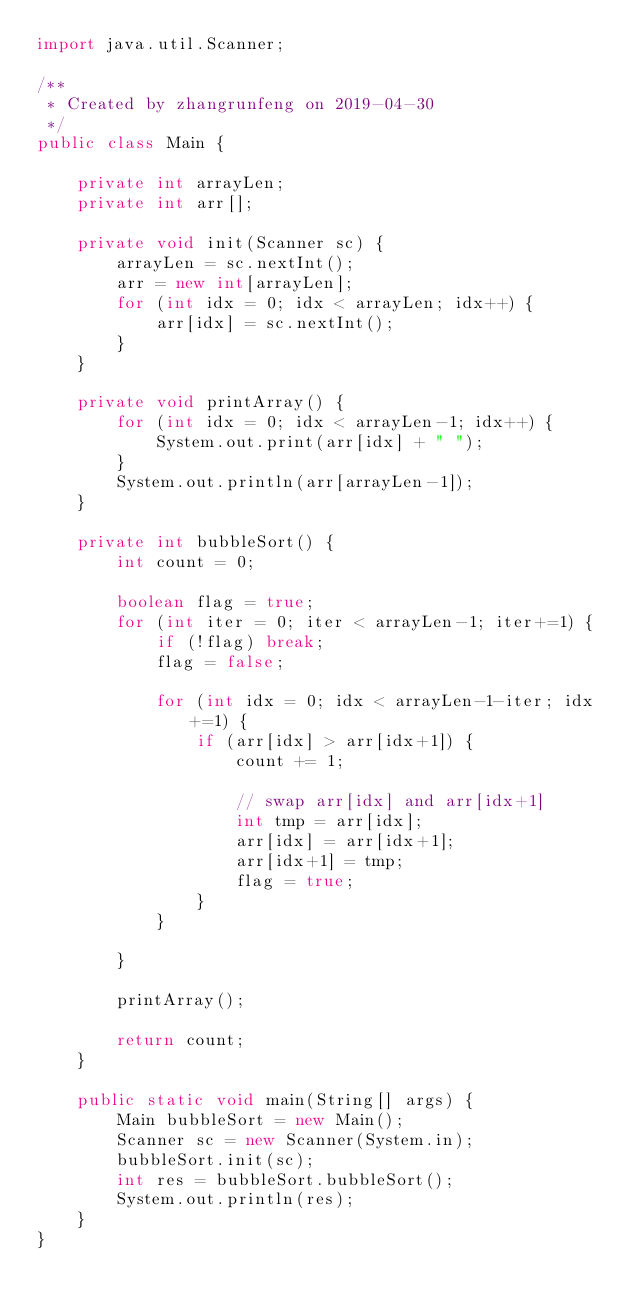<code> <loc_0><loc_0><loc_500><loc_500><_Java_>import java.util.Scanner;

/**
 * Created by zhangrunfeng on 2019-04-30
 */
public class Main {

    private int arrayLen;
    private int arr[];

    private void init(Scanner sc) {
        arrayLen = sc.nextInt();
        arr = new int[arrayLen];
        for (int idx = 0; idx < arrayLen; idx++) {
            arr[idx] = sc.nextInt();
        }
    }

    private void printArray() {
        for (int idx = 0; idx < arrayLen-1; idx++) {
            System.out.print(arr[idx] + " ");
        }
        System.out.println(arr[arrayLen-1]);
    }

    private int bubbleSort() {
        int count = 0;

        boolean flag = true;
        for (int iter = 0; iter < arrayLen-1; iter+=1) {
            if (!flag) break;
            flag = false;

            for (int idx = 0; idx < arrayLen-1-iter; idx+=1) {
                if (arr[idx] > arr[idx+1]) {
                    count += 1;

                    // swap arr[idx] and arr[idx+1]
                    int tmp = arr[idx];
                    arr[idx] = arr[idx+1];
                    arr[idx+1] = tmp;
                    flag = true;
                }
            }

        }

        printArray();

        return count;
    }

    public static void main(String[] args) {
        Main bubbleSort = new Main();
        Scanner sc = new Scanner(System.in);
        bubbleSort.init(sc);
        int res = bubbleSort.bubbleSort();
        System.out.println(res);
    }
}

</code> 